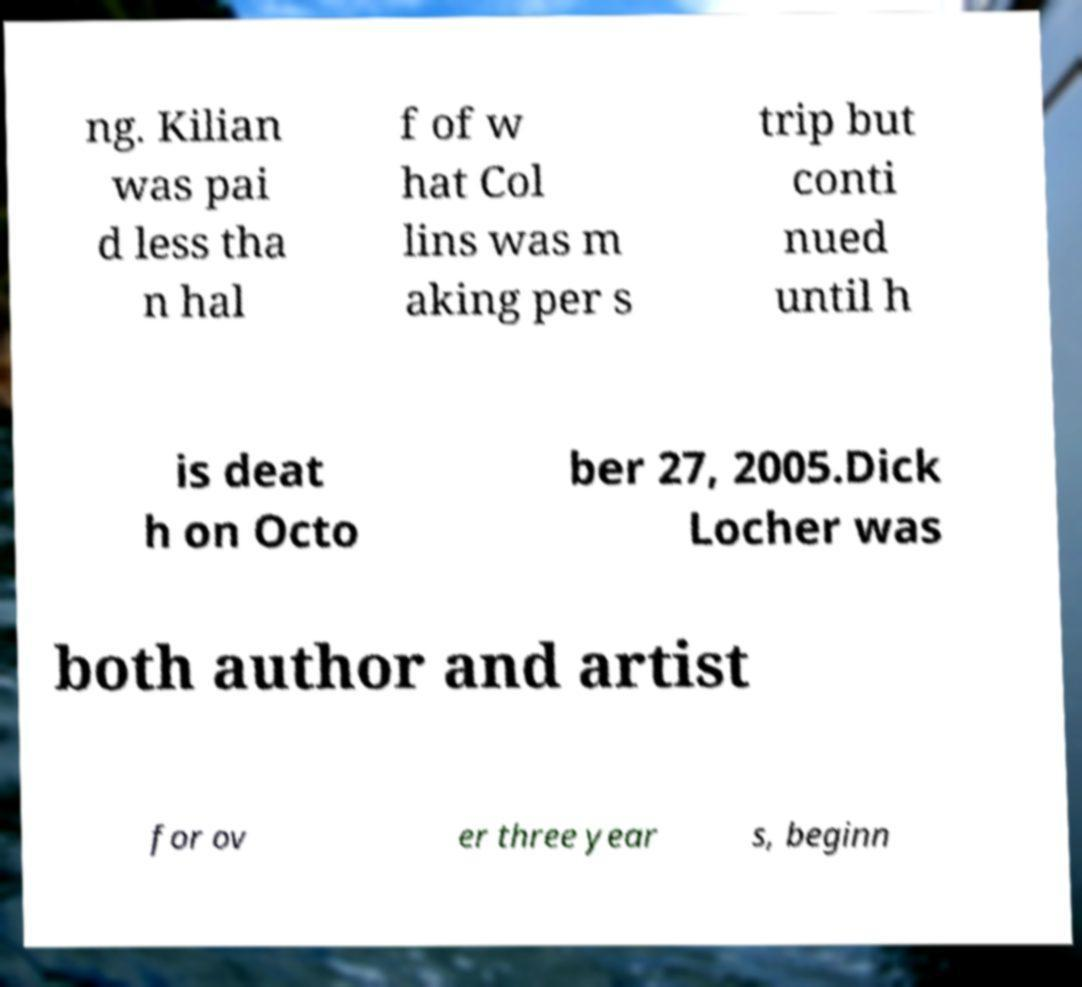Can you read and provide the text displayed in the image?This photo seems to have some interesting text. Can you extract and type it out for me? ng. Kilian was pai d less tha n hal f of w hat Col lins was m aking per s trip but conti nued until h is deat h on Octo ber 27, 2005.Dick Locher was both author and artist for ov er three year s, beginn 